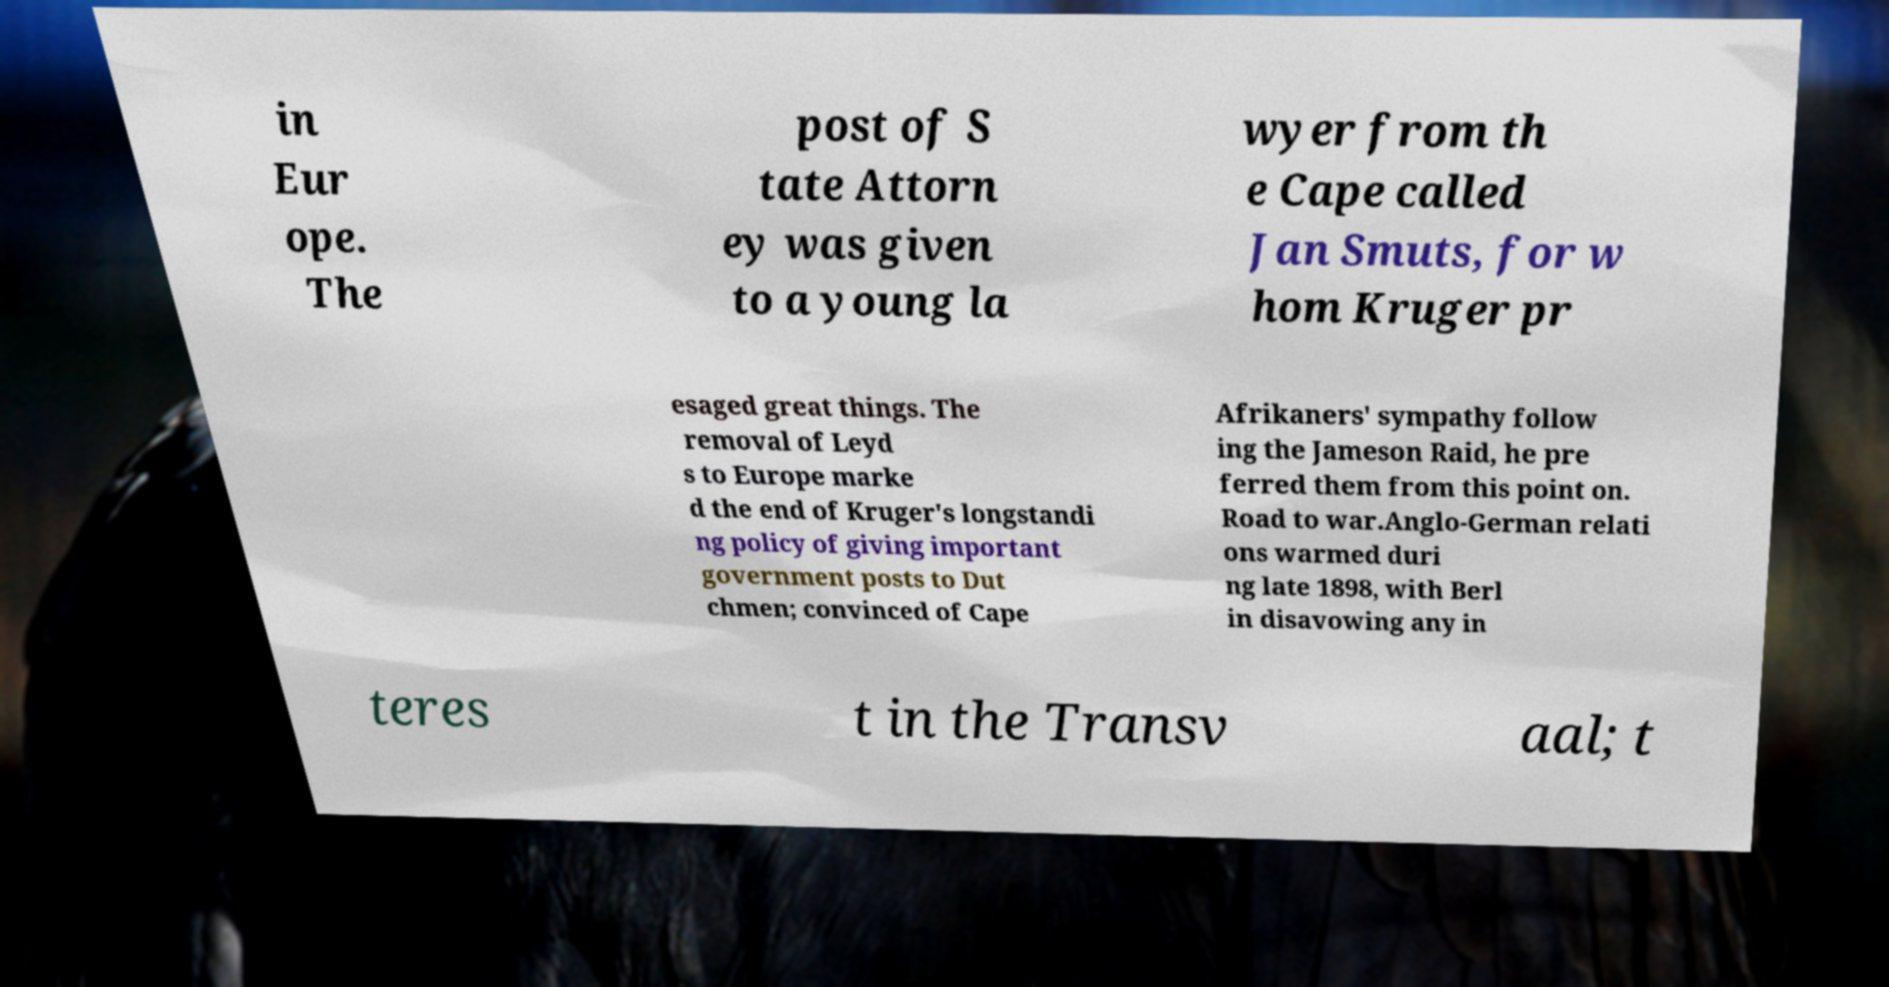There's text embedded in this image that I need extracted. Can you transcribe it verbatim? in Eur ope. The post of S tate Attorn ey was given to a young la wyer from th e Cape called Jan Smuts, for w hom Kruger pr esaged great things. The removal of Leyd s to Europe marke d the end of Kruger's longstandi ng policy of giving important government posts to Dut chmen; convinced of Cape Afrikaners' sympathy follow ing the Jameson Raid, he pre ferred them from this point on. Road to war.Anglo-German relati ons warmed duri ng late 1898, with Berl in disavowing any in teres t in the Transv aal; t 